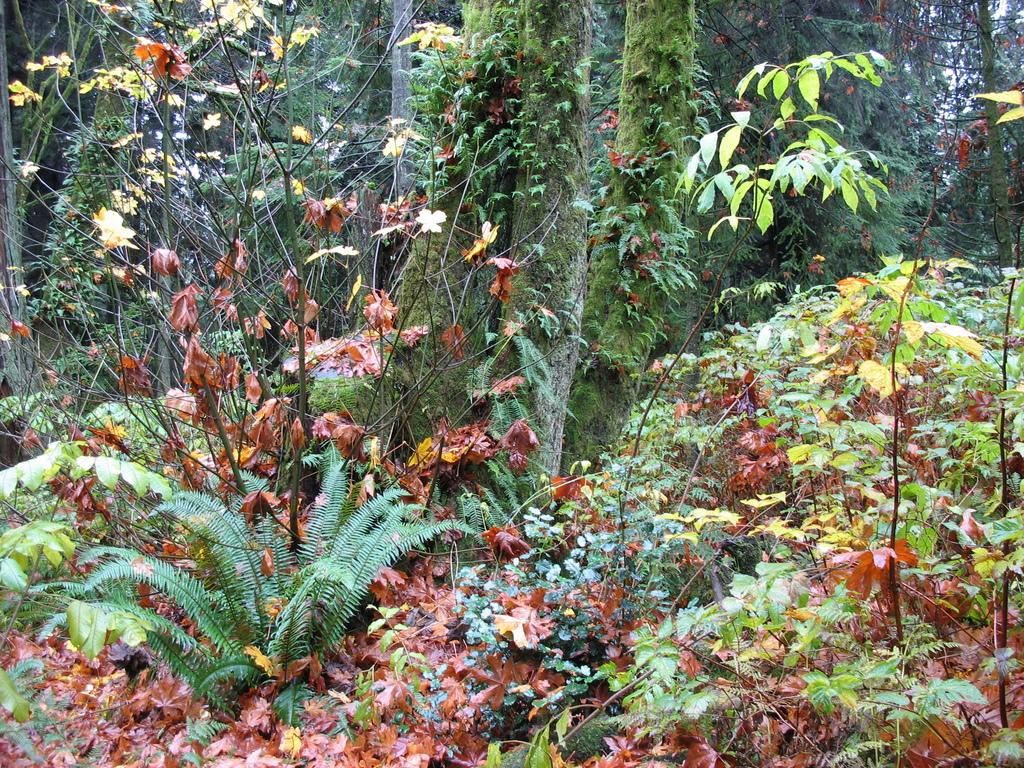What type of vegetation is in the foreground of the image? There are plants in the foreground of the image. What type of vegetation is in the background of the image? There are trees in the background of the image. What type of jeans can be seen hanging on the tree in the image? There are no jeans present in the image; it features plants in the foreground and trees in the background. What is the level of noise in the image? The image does not convey any information about the level of noise, as it only shows plants and trees. 